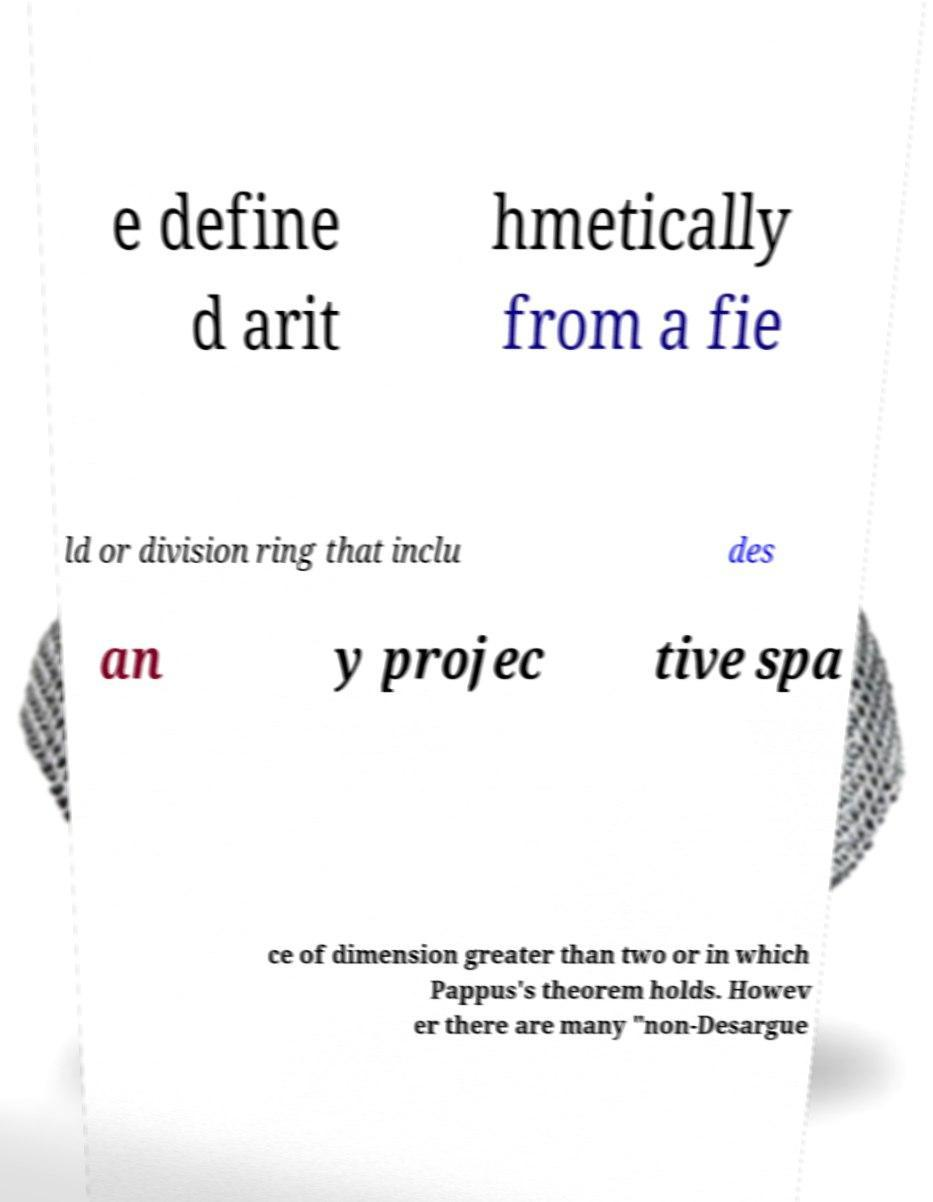Please identify and transcribe the text found in this image. e define d arit hmetically from a fie ld or division ring that inclu des an y projec tive spa ce of dimension greater than two or in which Pappus's theorem holds. Howev er there are many "non-Desargue 